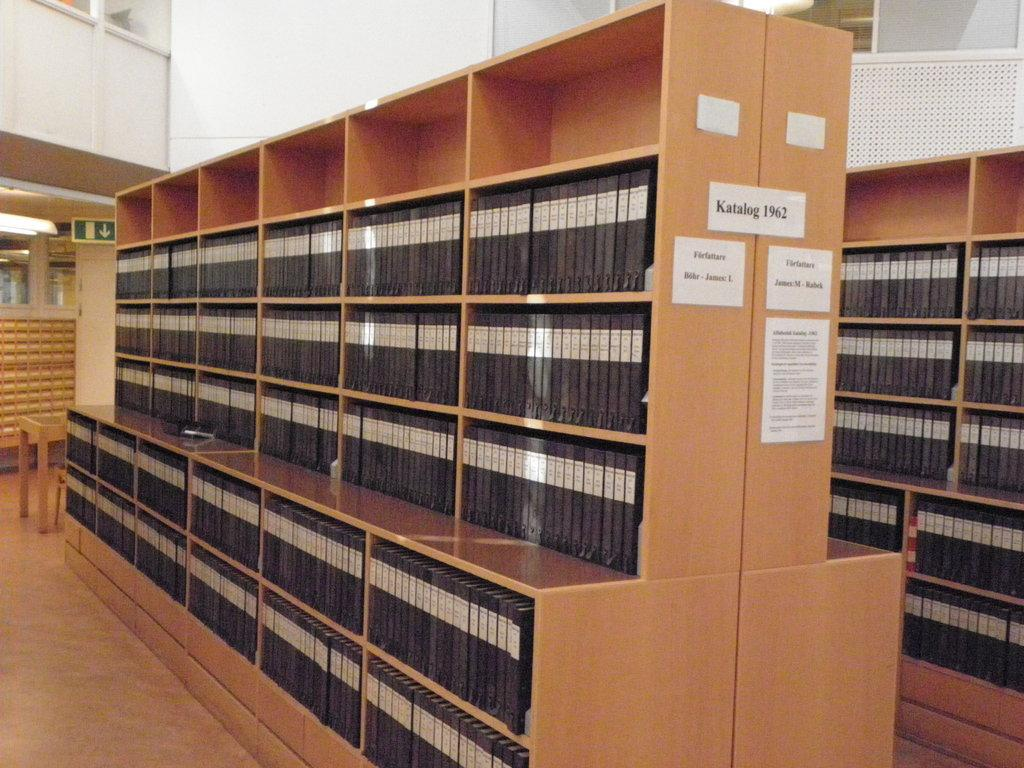<image>
Write a terse but informative summary of the picture. A bookshelf in a library is labeled Katalog 1962. 